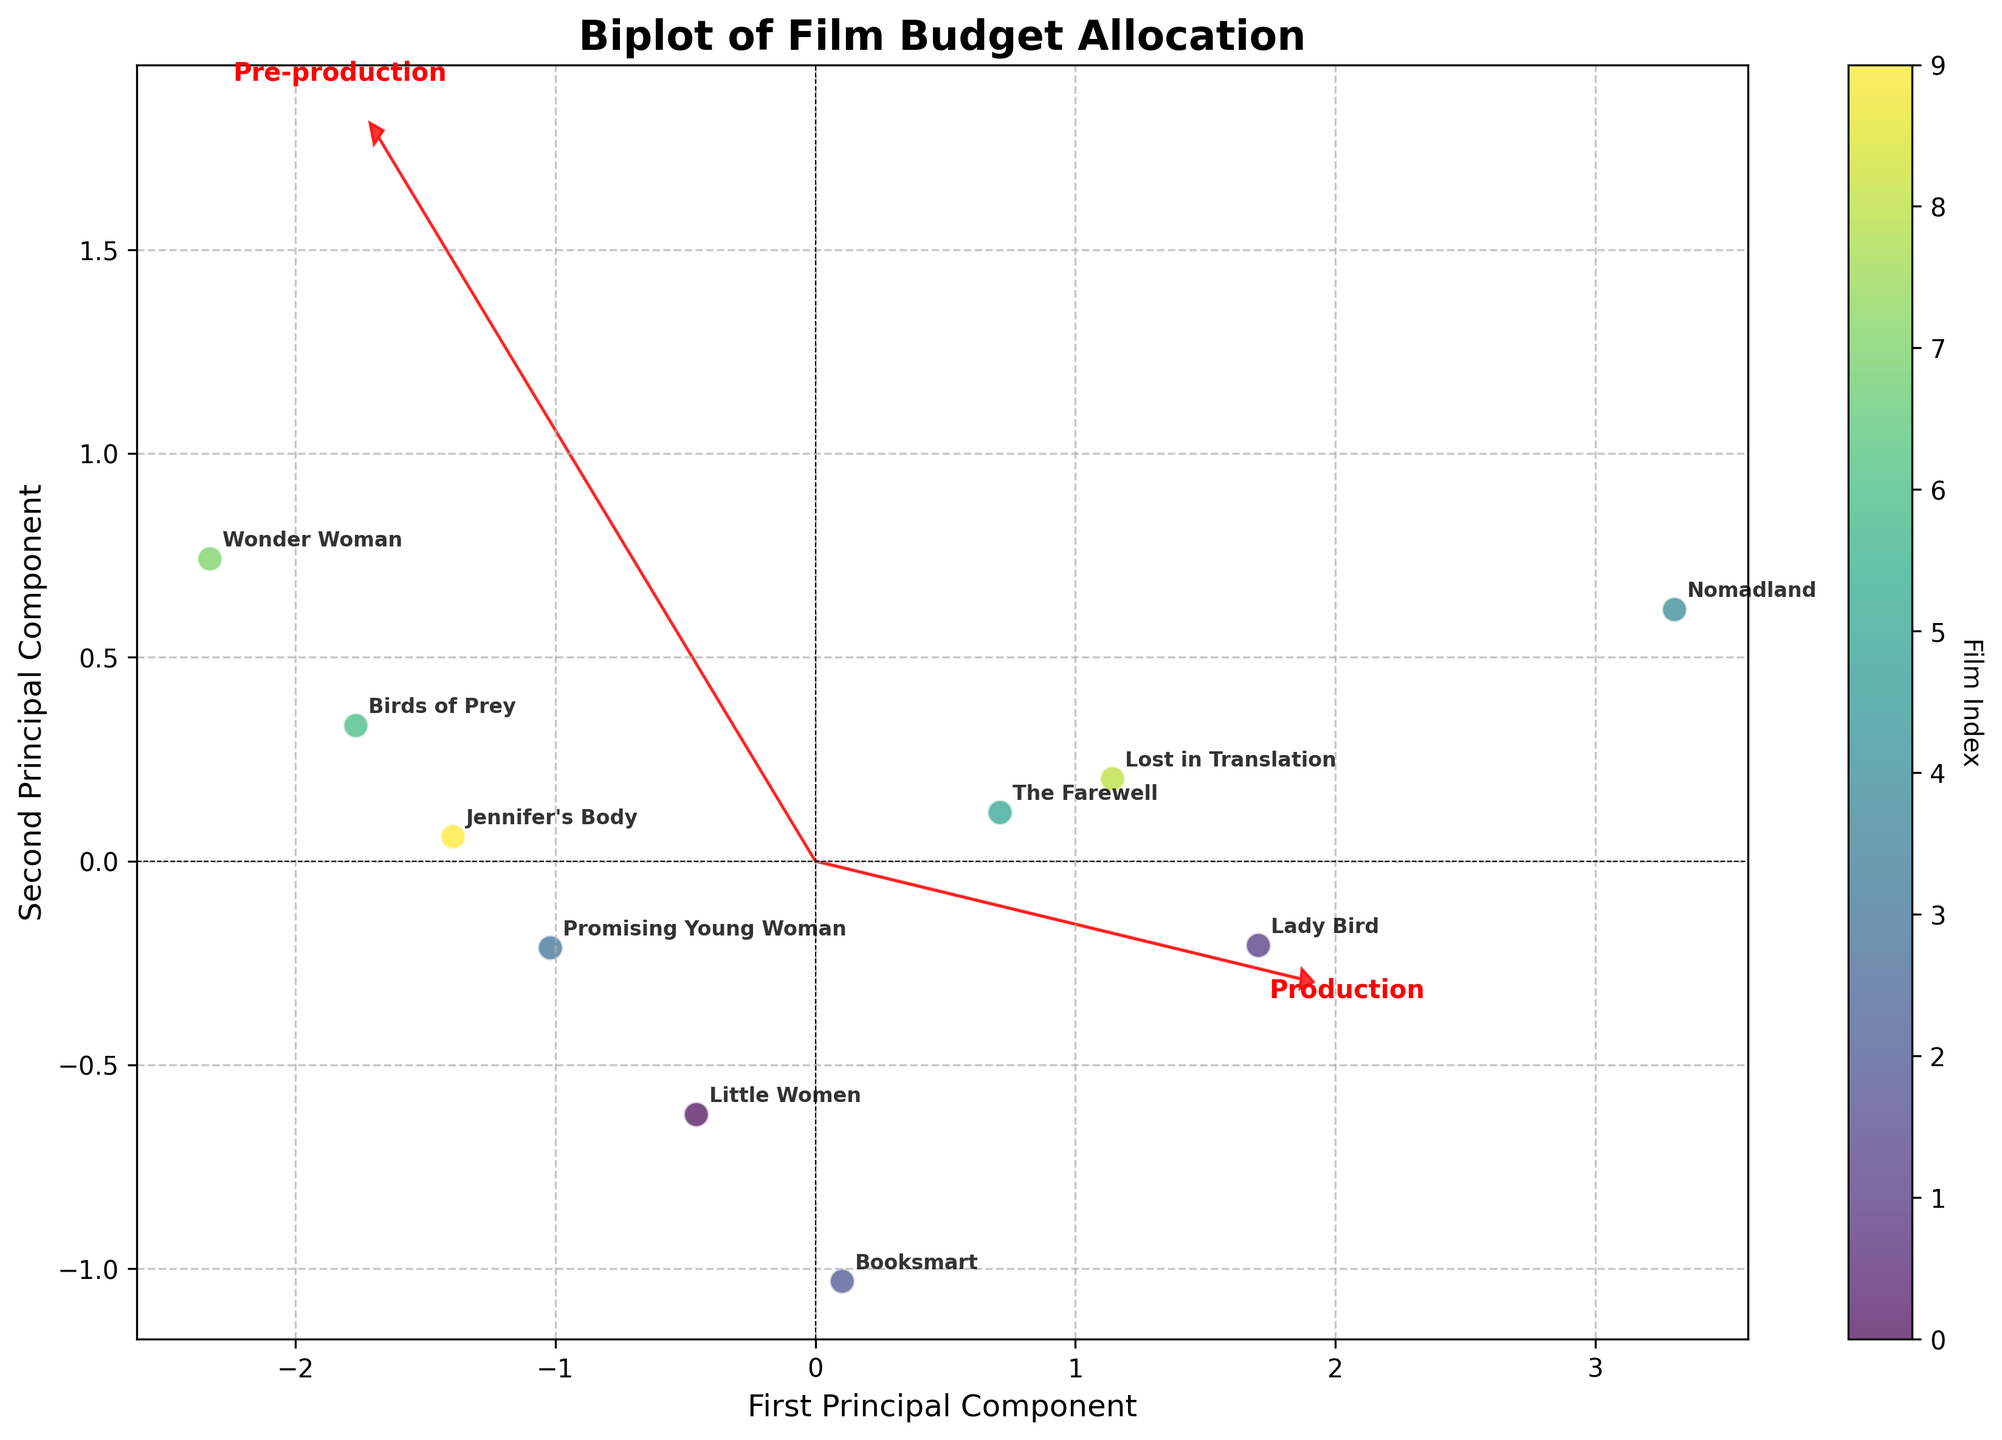What's the title of the figure? The title is displayed at the top center of the figure.
Answer: Biplot of Film Budget Allocation How many principal components are plotted on the axes? The axes labels indicate the components plotted. The x-axis is the "First Principal Component" and the y-axis is the "Second Principal Component."
Answer: Two Which film has the highest first principal component value? Look at the projected points along the x-axis (First Principal Component) and find the film with the highest value. The film "Nomadland" is positioned farthest to the right.
Answer: Nomadland Which budget phase vector is closest to the first principal component axis? Observe the red arrows indicating budget phases. The "Post-production" vector has the smallest angle with the first principal component axis.
Answer: Post-production How does "Lady Bird" compare to "Wonder Woman" in terms of the first principal component? Find the positions of both films along the x-axis. "Lady Bird" is to the left of "Wonder Woman," indicating a lower first principal component value.
Answer: Lady Bird has a lower first principal component value Does any film have an exact overlap in the plot? Check all the annotated points to see if any films are plotted at the same location. No two films are plotted at exactly the same coordinates.
Answer: No Which film has the closest projected point to the origin? Look for the film closest to the (0, 0) coordinate. "The Farewell" is the nearest to the origin.
Answer: The Farewell What does the arrow direction indicate in the biplot? The arrows represent the direction and magnitude of the three budget phases concerning the principal components. The direction the arrow points indicates the positive direction of the respective budget phase relative to the principal component scores.
Answer: Direction and magnitude of budget phases 